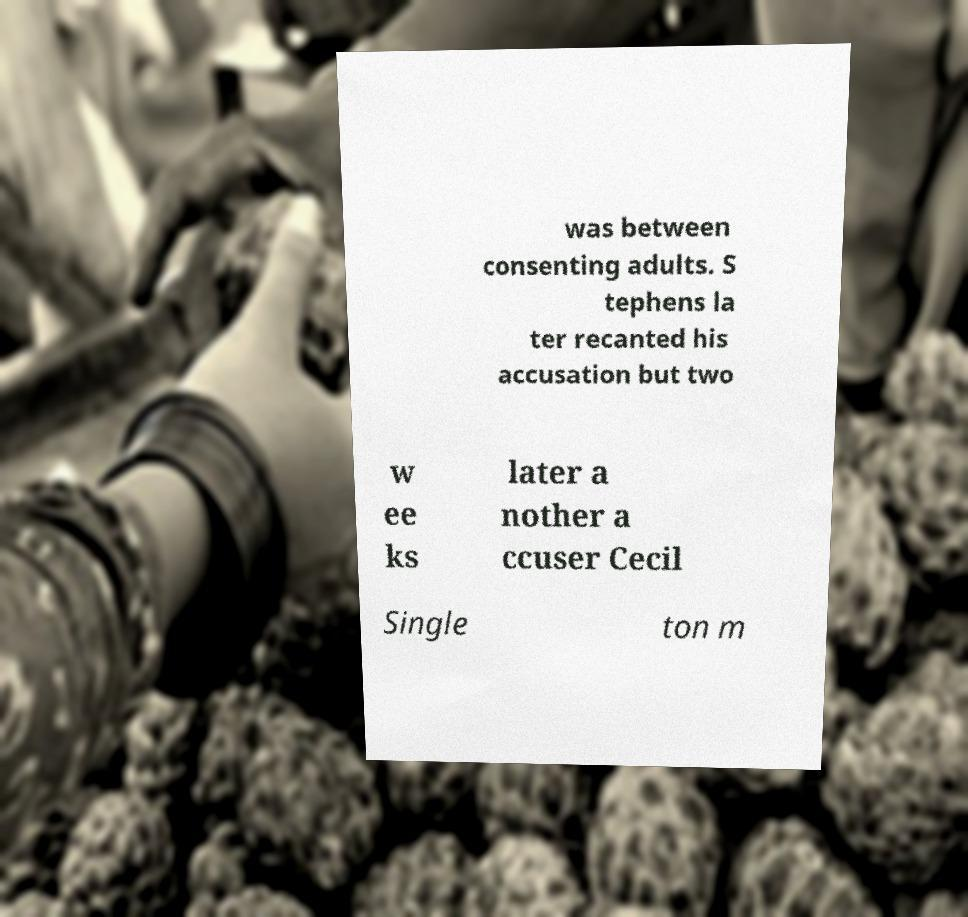There's text embedded in this image that I need extracted. Can you transcribe it verbatim? was between consenting adults. S tephens la ter recanted his accusation but two w ee ks later a nother a ccuser Cecil Single ton m 